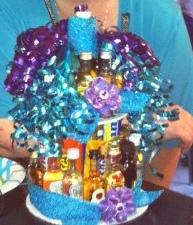What is in the small bottles?
Quick response, please. Liquor. Is that a little city made of booze?
Answer briefly. No. Does the person appear to be young?
Concise answer only. No. 